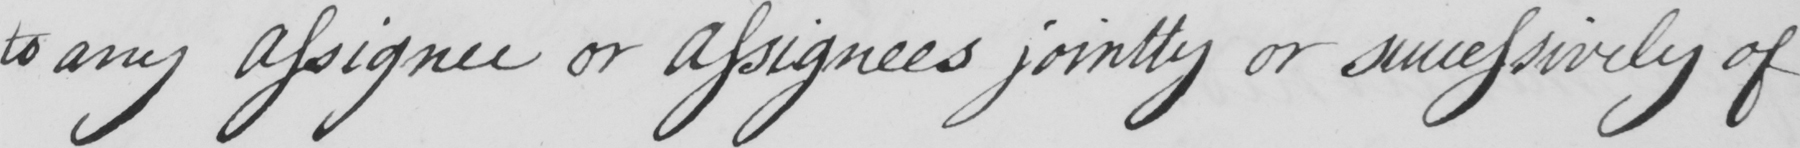Please provide the text content of this handwritten line. to any Assignee or Assignees jointly or sucessively of 